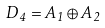<formula> <loc_0><loc_0><loc_500><loc_500>D _ { 4 } = A _ { 1 } \oplus A _ { 2 }</formula> 